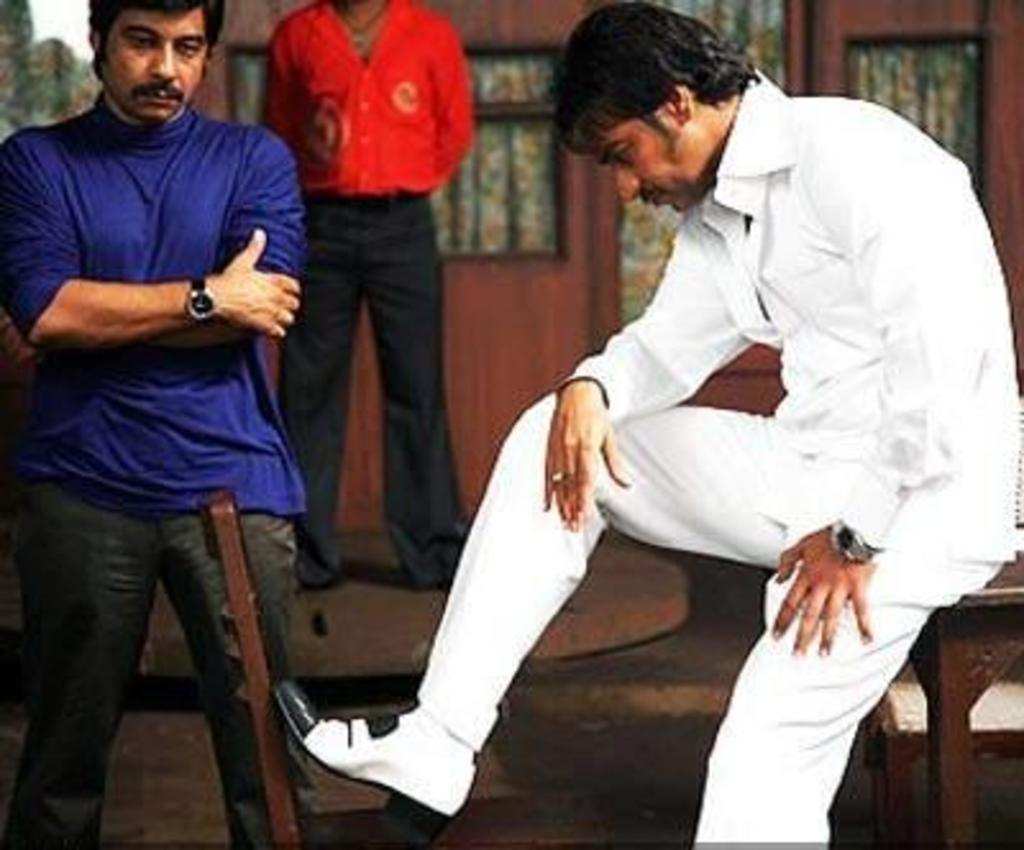What is: Who is the main subject in the image? There is a guy in the image. What is the guy wearing? The guy is dressed in white. What is the guy doing in the image? The guy is placing his leg on a chair. Can you describe the background of the image? There are two people standing in the background and a curtain is visible. What type of copper material can be seen in the image? There is no copper material present in the image. What is the guy requesting from the two people in the background? The image does not provide any information about the guy making a request to the two people in the background. 